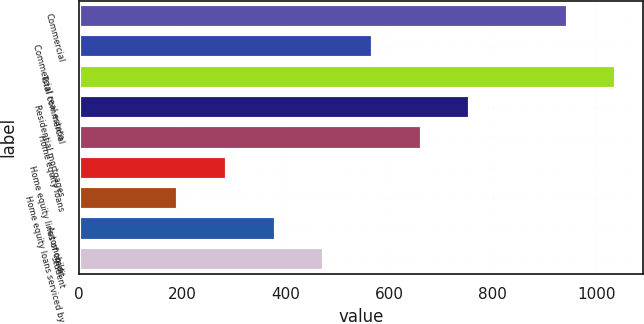Convert chart to OTSL. <chart><loc_0><loc_0><loc_500><loc_500><bar_chart><fcel>Commercial<fcel>Commercial real estate<fcel>Total commercial<fcel>Residential mortgages<fcel>Home equity loans<fcel>Home equity lines of credit<fcel>Home equity loans serviced by<fcel>Automobile<fcel>Student<nl><fcel>945<fcel>568.6<fcel>1039.1<fcel>756.8<fcel>662.7<fcel>286.3<fcel>192.2<fcel>380.4<fcel>474.5<nl></chart> 